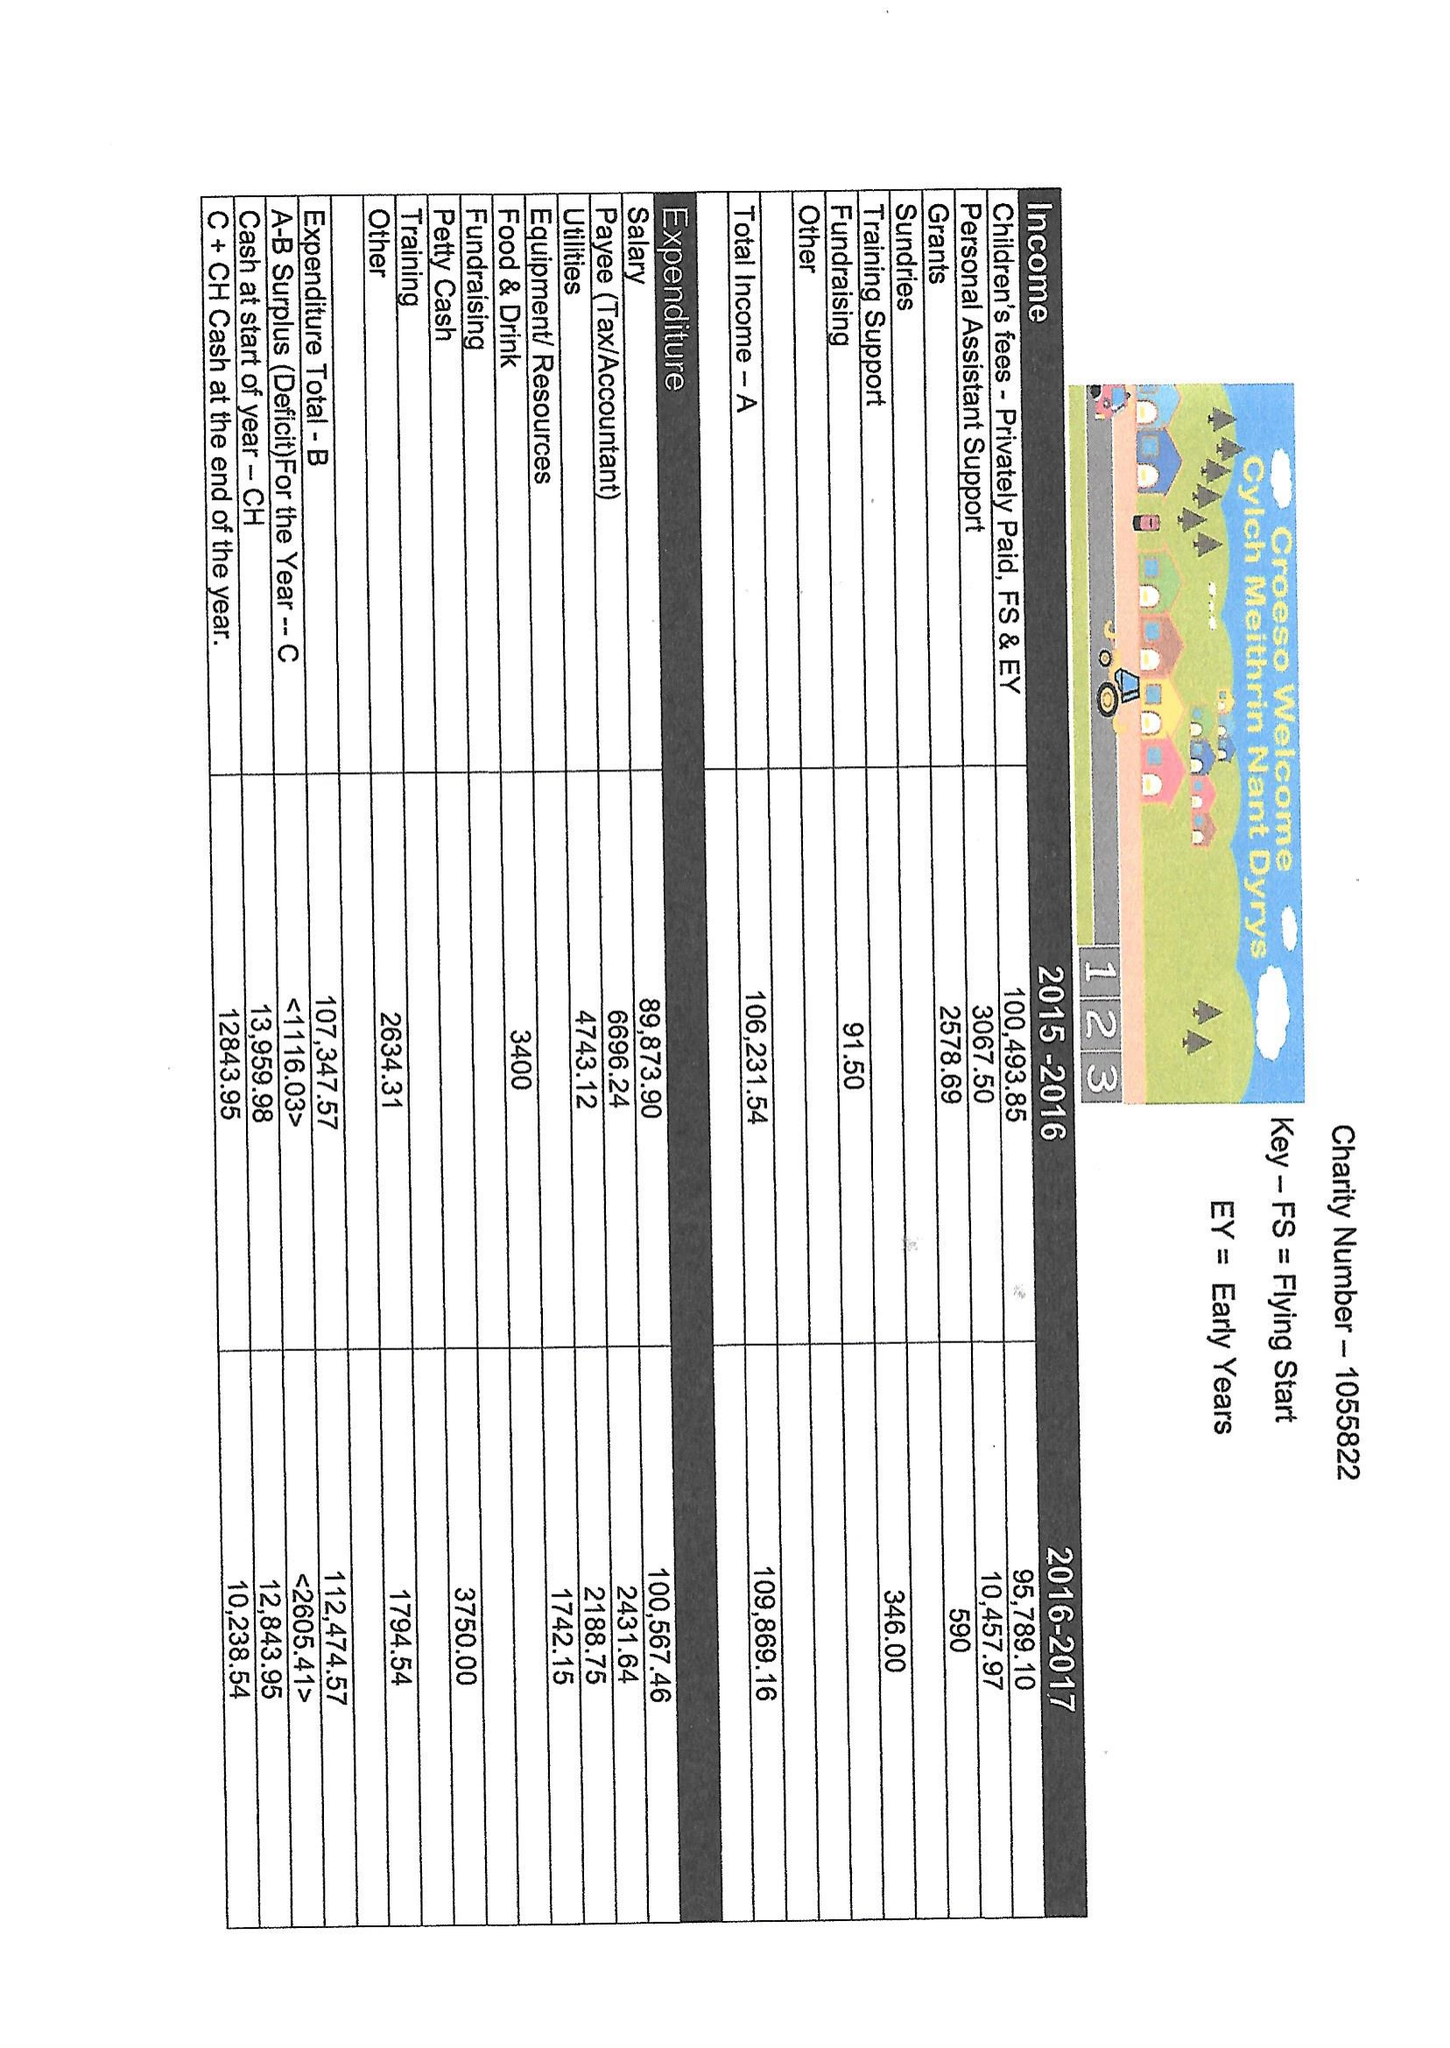What is the value for the income_annually_in_british_pounds?
Answer the question using a single word or phrase. 109869.16 